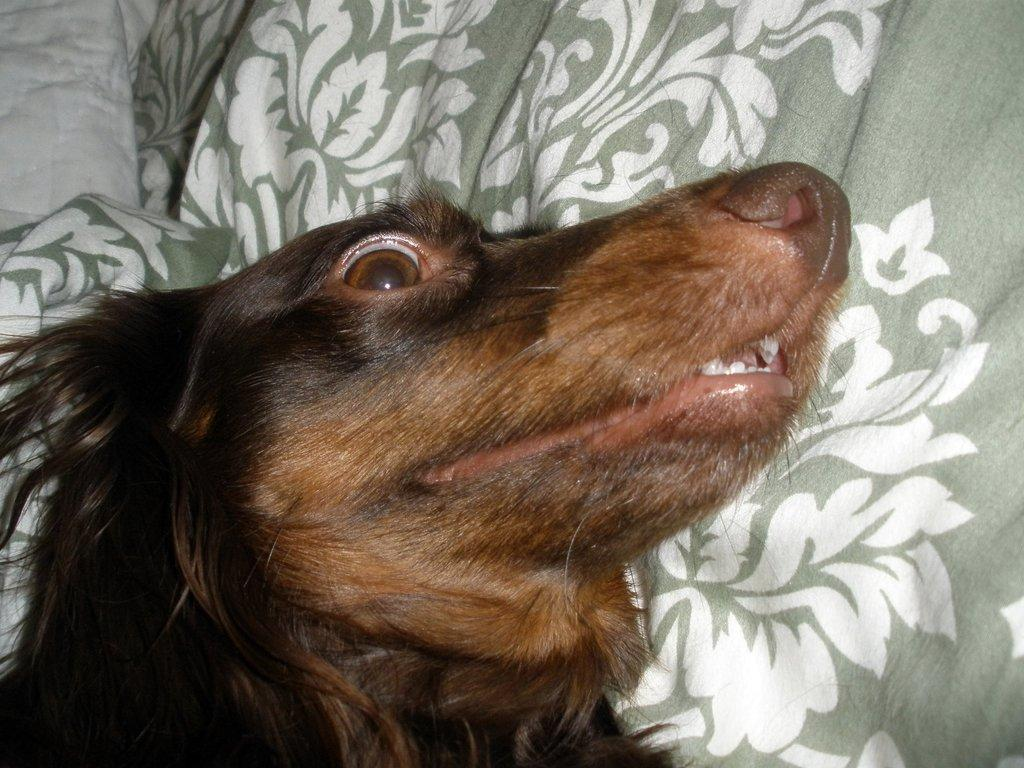What is the main subject in the center of the image? There is a dog in the center of the image. What can be seen in the background of the image? There is cloth visible in the background of the image. What is the purpose of the hall in the image? There is no hall present in the image; it only features a dog and cloth in the background. 